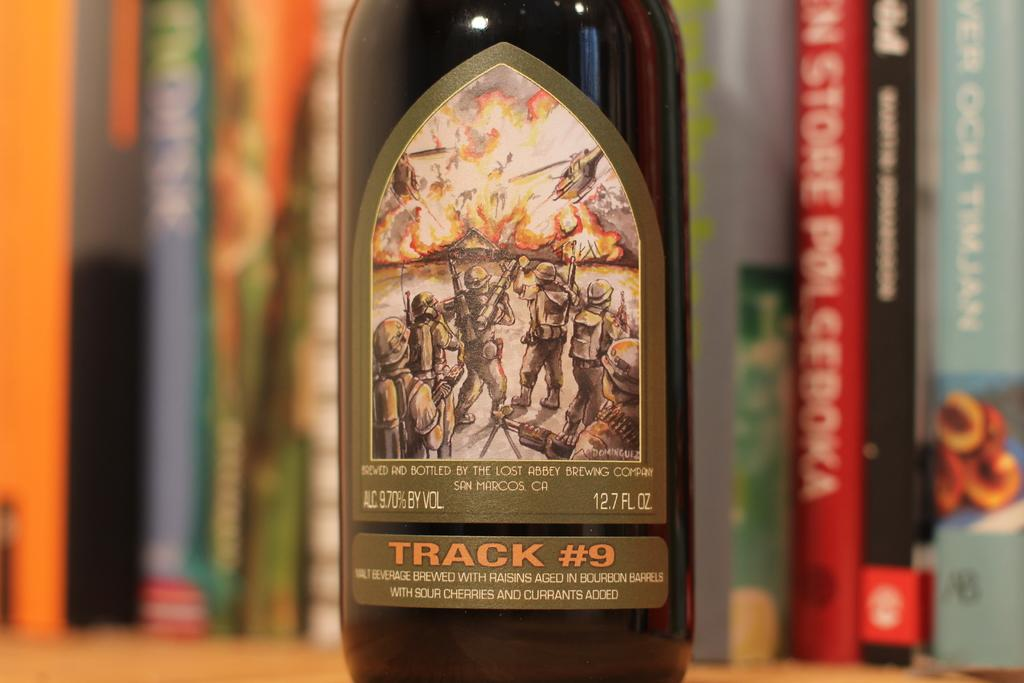<image>
Share a concise interpretation of the image provided. A bottled beverage with a 9.7% alcohol percentage. 